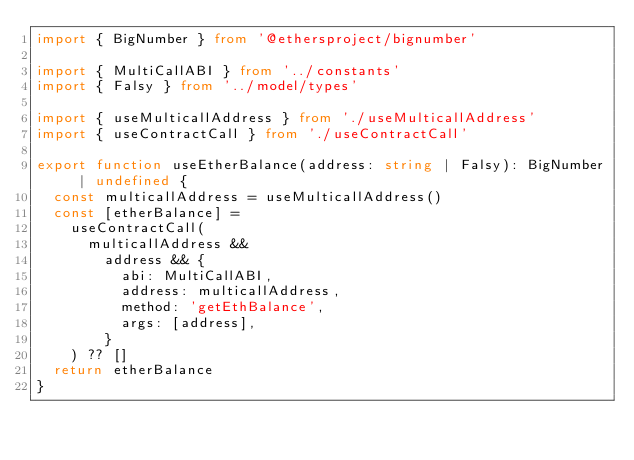<code> <loc_0><loc_0><loc_500><loc_500><_TypeScript_>import { BigNumber } from '@ethersproject/bignumber'

import { MultiCallABI } from '../constants'
import { Falsy } from '../model/types'

import { useMulticallAddress } from './useMulticallAddress'
import { useContractCall } from './useContractCall'

export function useEtherBalance(address: string | Falsy): BigNumber | undefined {
  const multicallAddress = useMulticallAddress()
  const [etherBalance] =
    useContractCall(
      multicallAddress &&
        address && {
          abi: MultiCallABI,
          address: multicallAddress,
          method: 'getEthBalance',
          args: [address],
        }
    ) ?? []
  return etherBalance
}
</code> 